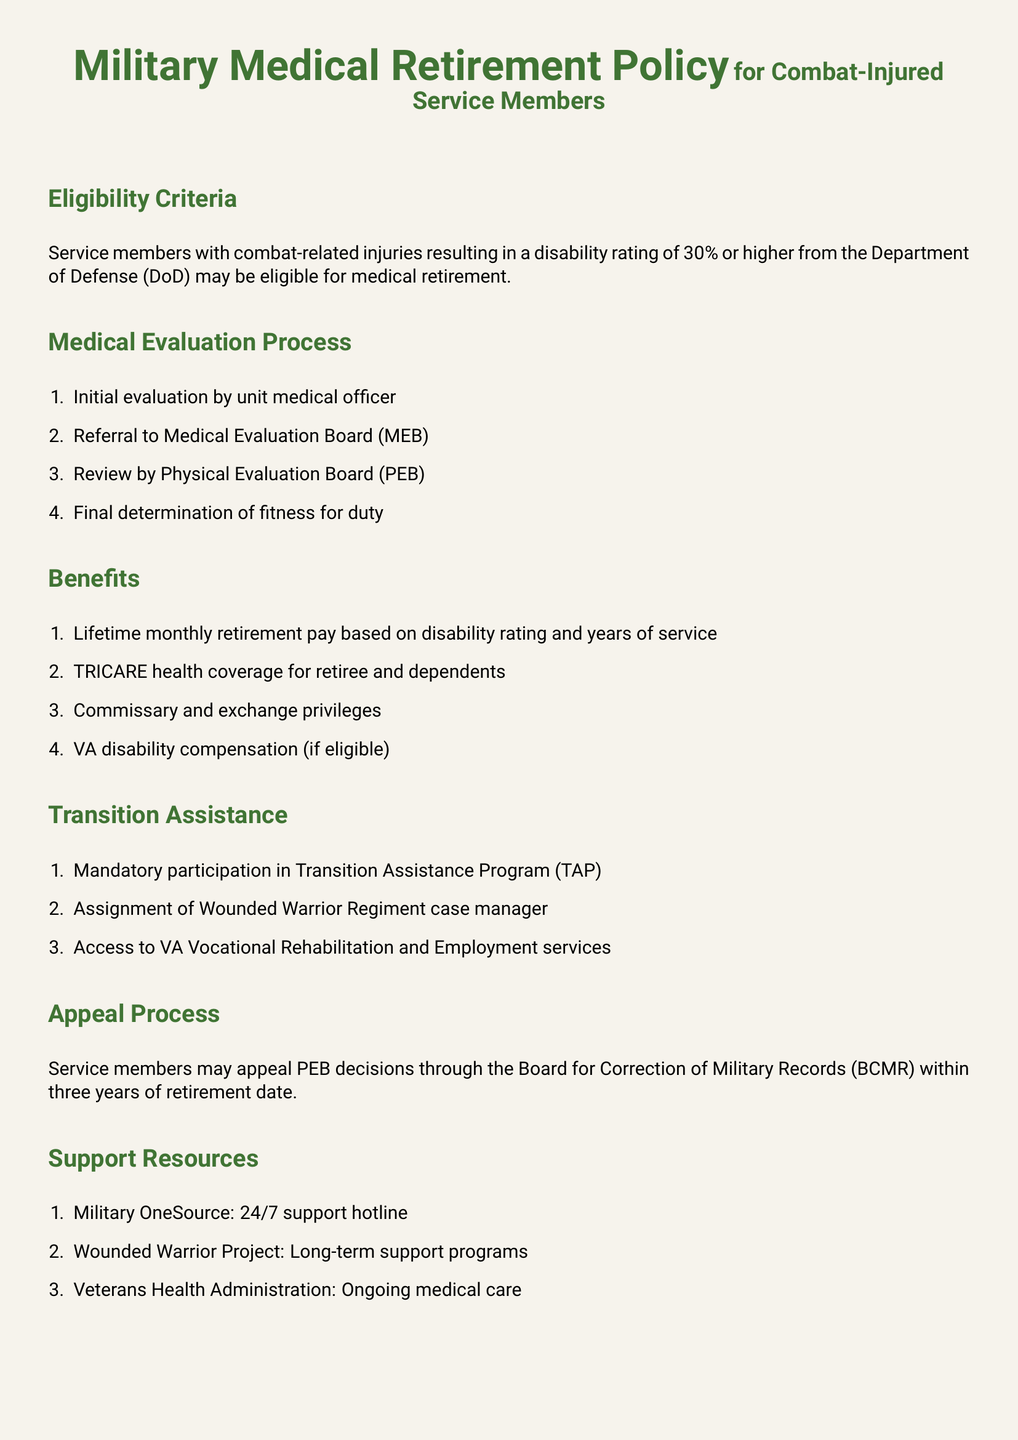What is the minimum disability rating for eligibility? The minimum disability rating for eligibility is specified as 30%.
Answer: 30% What is the first step in the medical evaluation process? The first step in the medical evaluation process is the initial evaluation by the unit medical officer.
Answer: Initial evaluation by unit medical officer What type of retirement pay do service members receive? Service members receive lifetime monthly retirement pay based on their disability rating and years of service.
Answer: Lifetime monthly retirement pay Which program must service members participate in? Service members must participate in the Transition Assistance Program (TAP).
Answer: Transition Assistance Program (TAP) What resources are available for ongoing medical care? The available resource for ongoing medical care is the Veterans Health Administration.
Answer: Veterans Health Administration What is the timeframe for appealing PEB decisions? The timeframe for appealing PEB decisions is three years from the retirement date.
Answer: Three years Who is assigned to assist during the transition process? A Wounded Warrior Regiment case manager is assigned to assist during the transition process.
Answer: Wounded Warrior Regiment case manager What health coverage do retirees receive? Retirees receive TRICARE health coverage.
Answer: TRICARE health coverage 